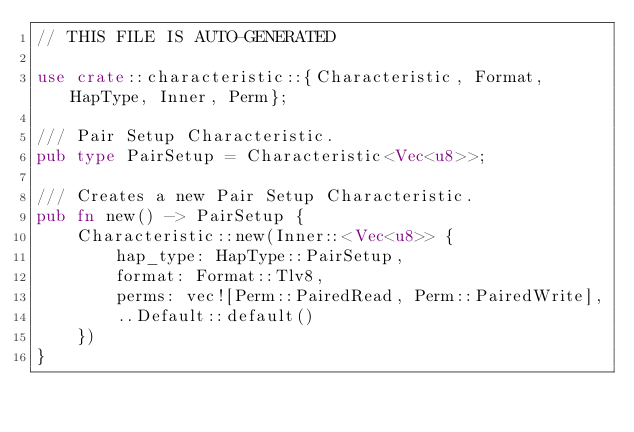Convert code to text. <code><loc_0><loc_0><loc_500><loc_500><_Rust_>// THIS FILE IS AUTO-GENERATED

use crate::characteristic::{Characteristic, Format, HapType, Inner, Perm};

/// Pair Setup Characteristic.
pub type PairSetup = Characteristic<Vec<u8>>;

/// Creates a new Pair Setup Characteristic.
pub fn new() -> PairSetup {
    Characteristic::new(Inner::<Vec<u8>> {
        hap_type: HapType::PairSetup,
        format: Format::Tlv8,
        perms: vec![Perm::PairedRead, Perm::PairedWrite],
        ..Default::default()
    })
}
</code> 